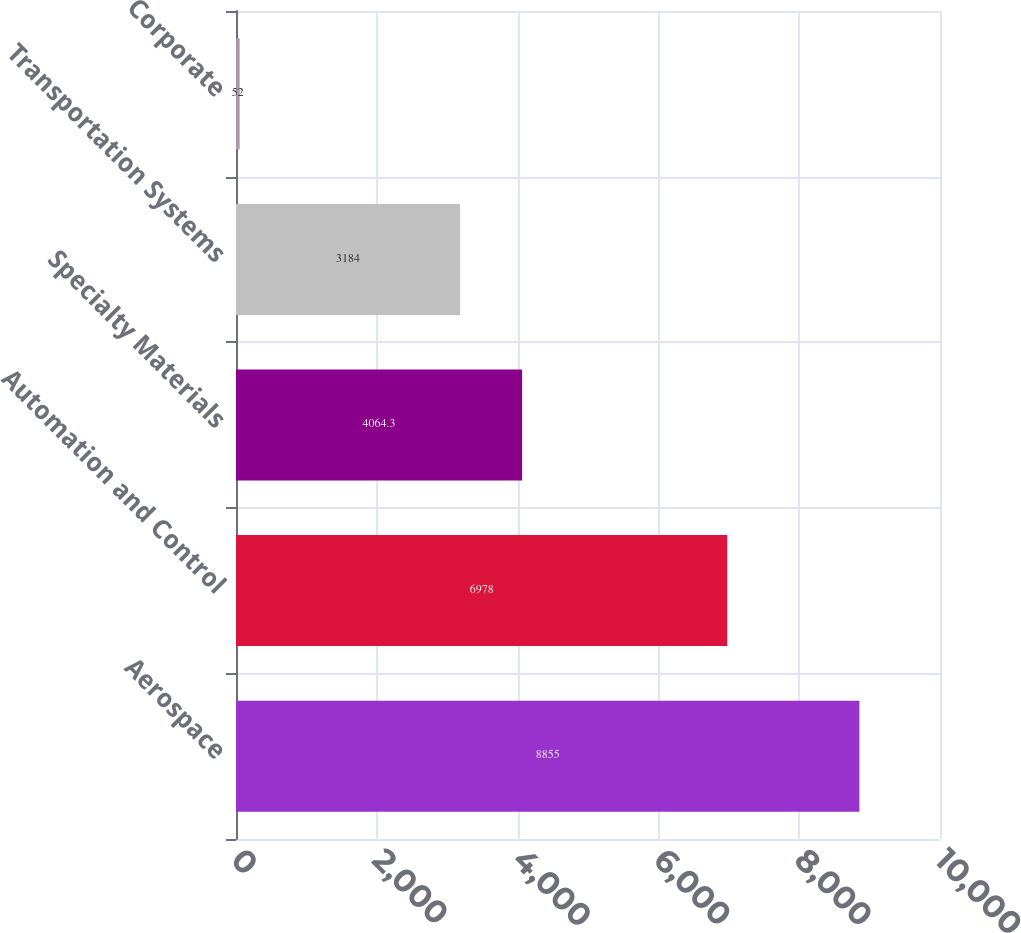Convert chart to OTSL. <chart><loc_0><loc_0><loc_500><loc_500><bar_chart><fcel>Aerospace<fcel>Automation and Control<fcel>Specialty Materials<fcel>Transportation Systems<fcel>Corporate<nl><fcel>8855<fcel>6978<fcel>4064.3<fcel>3184<fcel>52<nl></chart> 